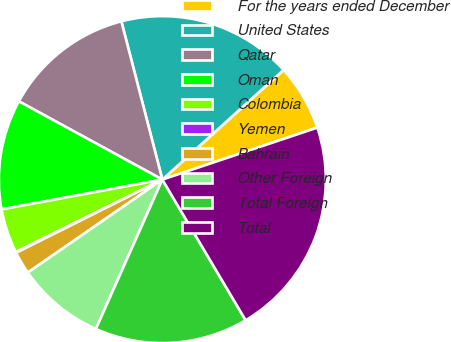Convert chart. <chart><loc_0><loc_0><loc_500><loc_500><pie_chart><fcel>For the years ended December<fcel>United States<fcel>Qatar<fcel>Oman<fcel>Colombia<fcel>Yemen<fcel>Bahrain<fcel>Other Foreign<fcel>Total Foreign<fcel>Total<nl><fcel>6.55%<fcel>17.33%<fcel>13.02%<fcel>10.86%<fcel>4.39%<fcel>0.08%<fcel>2.24%<fcel>8.71%<fcel>15.17%<fcel>21.64%<nl></chart> 